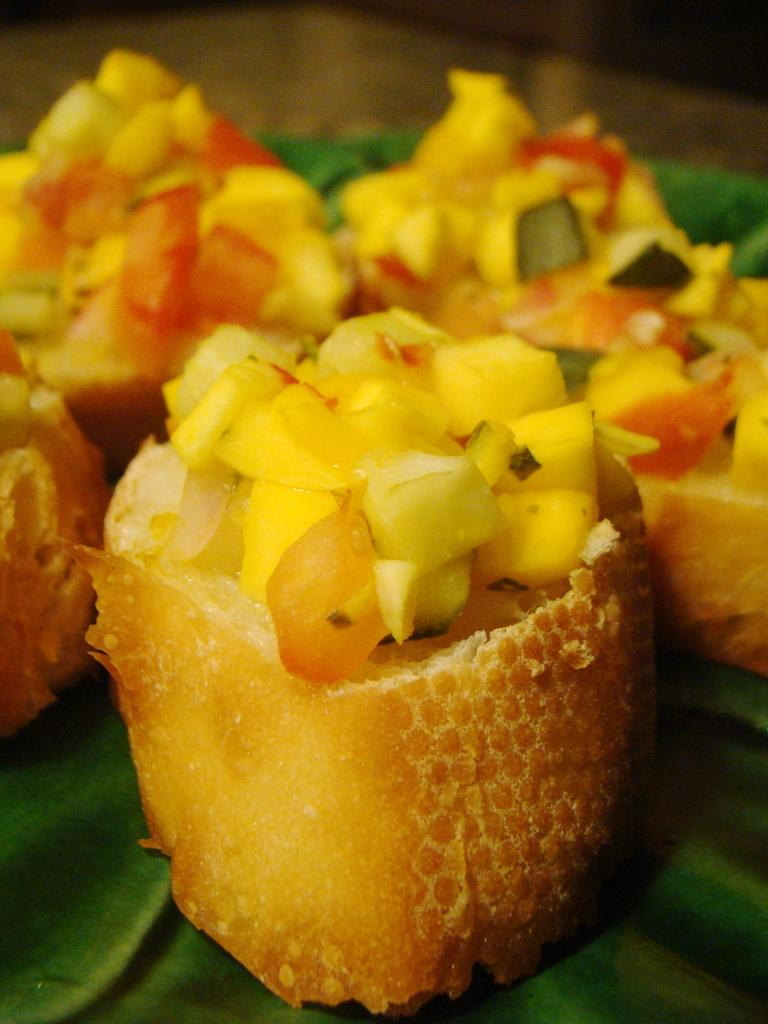What is present on the leaf in the image? There are eatable items on the leaf in the image. Can you describe the leaf in the image? The leaf appears to be green and is holding the eatable items. What type of kite is visible in the image? There is no kite present in the image. Can you tell me the name of the doctor who signed the receipt in the image? There is no receipt or doctor present in the image. 